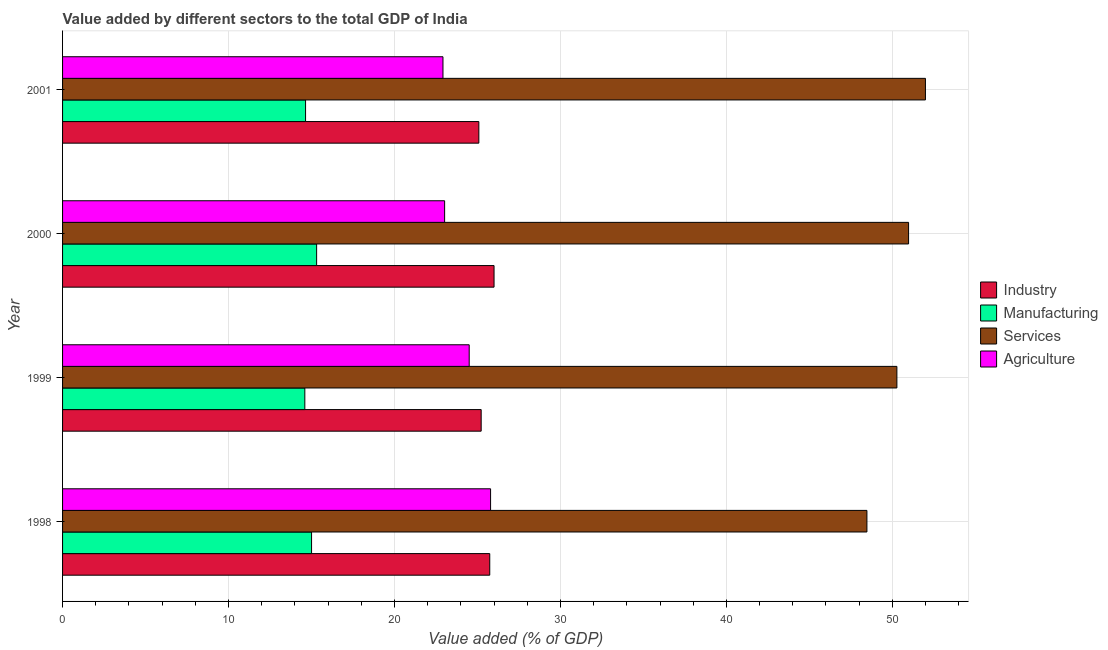How many groups of bars are there?
Keep it short and to the point. 4. Are the number of bars per tick equal to the number of legend labels?
Make the answer very short. Yes. Are the number of bars on each tick of the Y-axis equal?
Provide a succinct answer. Yes. How many bars are there on the 4th tick from the bottom?
Give a very brief answer. 4. In how many cases, is the number of bars for a given year not equal to the number of legend labels?
Make the answer very short. 0. What is the value added by agricultural sector in 2000?
Make the answer very short. 23.02. Across all years, what is the maximum value added by manufacturing sector?
Offer a very short reply. 15.31. Across all years, what is the minimum value added by services sector?
Your answer should be very brief. 48.47. What is the total value added by services sector in the graph?
Your response must be concise. 201.71. What is the difference between the value added by manufacturing sector in 2000 and that in 2001?
Your answer should be compact. 0.67. What is the difference between the value added by manufacturing sector in 2000 and the value added by services sector in 1999?
Ensure brevity in your answer.  -34.96. What is the average value added by services sector per year?
Ensure brevity in your answer.  50.43. In the year 1999, what is the difference between the value added by manufacturing sector and value added by services sector?
Give a very brief answer. -35.68. What is the ratio of the value added by industrial sector in 1999 to that in 2001?
Offer a very short reply. 1.01. What is the difference between the highest and the second highest value added by agricultural sector?
Provide a succinct answer. 1.29. What is the difference between the highest and the lowest value added by agricultural sector?
Provide a succinct answer. 2.87. In how many years, is the value added by services sector greater than the average value added by services sector taken over all years?
Your response must be concise. 2. What does the 4th bar from the top in 1998 represents?
Offer a very short reply. Industry. What does the 2nd bar from the bottom in 2000 represents?
Give a very brief answer. Manufacturing. Is it the case that in every year, the sum of the value added by industrial sector and value added by manufacturing sector is greater than the value added by services sector?
Your answer should be very brief. No. How many bars are there?
Make the answer very short. 16. Are all the bars in the graph horizontal?
Your answer should be compact. Yes. What is the difference between two consecutive major ticks on the X-axis?
Keep it short and to the point. 10. Are the values on the major ticks of X-axis written in scientific E-notation?
Ensure brevity in your answer.  No. Does the graph contain any zero values?
Ensure brevity in your answer.  No. Does the graph contain grids?
Your answer should be compact. Yes. How are the legend labels stacked?
Provide a short and direct response. Vertical. What is the title of the graph?
Make the answer very short. Value added by different sectors to the total GDP of India. What is the label or title of the X-axis?
Ensure brevity in your answer.  Value added (% of GDP). What is the label or title of the Y-axis?
Provide a succinct answer. Year. What is the Value added (% of GDP) in Industry in 1998?
Offer a very short reply. 25.74. What is the Value added (% of GDP) of Manufacturing in 1998?
Give a very brief answer. 15. What is the Value added (% of GDP) in Services in 1998?
Your answer should be compact. 48.47. What is the Value added (% of GDP) of Agriculture in 1998?
Offer a terse response. 25.79. What is the Value added (% of GDP) in Industry in 1999?
Ensure brevity in your answer.  25.22. What is the Value added (% of GDP) in Manufacturing in 1999?
Provide a succinct answer. 14.6. What is the Value added (% of GDP) of Services in 1999?
Give a very brief answer. 50.27. What is the Value added (% of GDP) in Agriculture in 1999?
Make the answer very short. 24.5. What is the Value added (% of GDP) in Industry in 2000?
Ensure brevity in your answer.  26. What is the Value added (% of GDP) in Manufacturing in 2000?
Offer a terse response. 15.31. What is the Value added (% of GDP) of Services in 2000?
Ensure brevity in your answer.  50.98. What is the Value added (% of GDP) in Agriculture in 2000?
Your response must be concise. 23.02. What is the Value added (% of GDP) in Industry in 2001?
Make the answer very short. 25.08. What is the Value added (% of GDP) in Manufacturing in 2001?
Provide a succinct answer. 14.64. What is the Value added (% of GDP) in Services in 2001?
Your response must be concise. 51.99. What is the Value added (% of GDP) in Agriculture in 2001?
Your answer should be compact. 22.92. Across all years, what is the maximum Value added (% of GDP) of Industry?
Your answer should be compact. 26. Across all years, what is the maximum Value added (% of GDP) in Manufacturing?
Offer a very short reply. 15.31. Across all years, what is the maximum Value added (% of GDP) in Services?
Give a very brief answer. 51.99. Across all years, what is the maximum Value added (% of GDP) in Agriculture?
Keep it short and to the point. 25.79. Across all years, what is the minimum Value added (% of GDP) in Industry?
Provide a short and direct response. 25.08. Across all years, what is the minimum Value added (% of GDP) in Manufacturing?
Your response must be concise. 14.6. Across all years, what is the minimum Value added (% of GDP) in Services?
Offer a terse response. 48.47. Across all years, what is the minimum Value added (% of GDP) in Agriculture?
Keep it short and to the point. 22.92. What is the total Value added (% of GDP) of Industry in the graph?
Provide a short and direct response. 102.05. What is the total Value added (% of GDP) in Manufacturing in the graph?
Provide a succinct answer. 59.55. What is the total Value added (% of GDP) of Services in the graph?
Ensure brevity in your answer.  201.71. What is the total Value added (% of GDP) in Agriculture in the graph?
Your response must be concise. 96.24. What is the difference between the Value added (% of GDP) of Industry in 1998 and that in 1999?
Make the answer very short. 0.52. What is the difference between the Value added (% of GDP) of Manufacturing in 1998 and that in 1999?
Offer a very short reply. 0.41. What is the difference between the Value added (% of GDP) of Services in 1998 and that in 1999?
Ensure brevity in your answer.  -1.81. What is the difference between the Value added (% of GDP) of Agriculture in 1998 and that in 1999?
Offer a very short reply. 1.29. What is the difference between the Value added (% of GDP) of Industry in 1998 and that in 2000?
Provide a succinct answer. -0.26. What is the difference between the Value added (% of GDP) of Manufacturing in 1998 and that in 2000?
Provide a succinct answer. -0.31. What is the difference between the Value added (% of GDP) of Services in 1998 and that in 2000?
Your answer should be compact. -2.51. What is the difference between the Value added (% of GDP) in Agriculture in 1998 and that in 2000?
Ensure brevity in your answer.  2.77. What is the difference between the Value added (% of GDP) in Industry in 1998 and that in 2001?
Offer a terse response. 0.66. What is the difference between the Value added (% of GDP) of Manufacturing in 1998 and that in 2001?
Your answer should be compact. 0.36. What is the difference between the Value added (% of GDP) in Services in 1998 and that in 2001?
Provide a succinct answer. -3.53. What is the difference between the Value added (% of GDP) of Agriculture in 1998 and that in 2001?
Give a very brief answer. 2.87. What is the difference between the Value added (% of GDP) in Industry in 1999 and that in 2000?
Provide a short and direct response. -0.78. What is the difference between the Value added (% of GDP) in Manufacturing in 1999 and that in 2000?
Keep it short and to the point. -0.71. What is the difference between the Value added (% of GDP) in Services in 1999 and that in 2000?
Your response must be concise. -0.7. What is the difference between the Value added (% of GDP) of Agriculture in 1999 and that in 2000?
Provide a succinct answer. 1.48. What is the difference between the Value added (% of GDP) in Industry in 1999 and that in 2001?
Provide a succinct answer. 0.14. What is the difference between the Value added (% of GDP) in Manufacturing in 1999 and that in 2001?
Ensure brevity in your answer.  -0.04. What is the difference between the Value added (% of GDP) of Services in 1999 and that in 2001?
Your answer should be compact. -1.72. What is the difference between the Value added (% of GDP) in Agriculture in 1999 and that in 2001?
Provide a short and direct response. 1.58. What is the difference between the Value added (% of GDP) of Industry in 2000 and that in 2001?
Make the answer very short. 0.92. What is the difference between the Value added (% of GDP) of Manufacturing in 2000 and that in 2001?
Ensure brevity in your answer.  0.67. What is the difference between the Value added (% of GDP) of Services in 2000 and that in 2001?
Provide a short and direct response. -1.02. What is the difference between the Value added (% of GDP) of Agriculture in 2000 and that in 2001?
Provide a succinct answer. 0.1. What is the difference between the Value added (% of GDP) of Industry in 1998 and the Value added (% of GDP) of Manufacturing in 1999?
Give a very brief answer. 11.14. What is the difference between the Value added (% of GDP) of Industry in 1998 and the Value added (% of GDP) of Services in 1999?
Provide a short and direct response. -24.53. What is the difference between the Value added (% of GDP) in Industry in 1998 and the Value added (% of GDP) in Agriculture in 1999?
Keep it short and to the point. 1.24. What is the difference between the Value added (% of GDP) of Manufacturing in 1998 and the Value added (% of GDP) of Services in 1999?
Your answer should be compact. -35.27. What is the difference between the Value added (% of GDP) of Manufacturing in 1998 and the Value added (% of GDP) of Agriculture in 1999?
Provide a short and direct response. -9.5. What is the difference between the Value added (% of GDP) in Services in 1998 and the Value added (% of GDP) in Agriculture in 1999?
Give a very brief answer. 23.97. What is the difference between the Value added (% of GDP) in Industry in 1998 and the Value added (% of GDP) in Manufacturing in 2000?
Keep it short and to the point. 10.43. What is the difference between the Value added (% of GDP) in Industry in 1998 and the Value added (% of GDP) in Services in 2000?
Offer a very short reply. -25.24. What is the difference between the Value added (% of GDP) in Industry in 1998 and the Value added (% of GDP) in Agriculture in 2000?
Offer a very short reply. 2.72. What is the difference between the Value added (% of GDP) of Manufacturing in 1998 and the Value added (% of GDP) of Services in 2000?
Your answer should be very brief. -35.97. What is the difference between the Value added (% of GDP) of Manufacturing in 1998 and the Value added (% of GDP) of Agriculture in 2000?
Your answer should be very brief. -8.02. What is the difference between the Value added (% of GDP) of Services in 1998 and the Value added (% of GDP) of Agriculture in 2000?
Your answer should be very brief. 25.45. What is the difference between the Value added (% of GDP) in Industry in 1998 and the Value added (% of GDP) in Manufacturing in 2001?
Offer a very short reply. 11.1. What is the difference between the Value added (% of GDP) in Industry in 1998 and the Value added (% of GDP) in Services in 2001?
Keep it short and to the point. -26.25. What is the difference between the Value added (% of GDP) of Industry in 1998 and the Value added (% of GDP) of Agriculture in 2001?
Offer a terse response. 2.82. What is the difference between the Value added (% of GDP) of Manufacturing in 1998 and the Value added (% of GDP) of Services in 2001?
Keep it short and to the point. -36.99. What is the difference between the Value added (% of GDP) in Manufacturing in 1998 and the Value added (% of GDP) in Agriculture in 2001?
Your answer should be very brief. -7.92. What is the difference between the Value added (% of GDP) of Services in 1998 and the Value added (% of GDP) of Agriculture in 2001?
Ensure brevity in your answer.  25.55. What is the difference between the Value added (% of GDP) of Industry in 1999 and the Value added (% of GDP) of Manufacturing in 2000?
Provide a short and direct response. 9.92. What is the difference between the Value added (% of GDP) of Industry in 1999 and the Value added (% of GDP) of Services in 2000?
Ensure brevity in your answer.  -25.75. What is the difference between the Value added (% of GDP) in Industry in 1999 and the Value added (% of GDP) in Agriculture in 2000?
Offer a very short reply. 2.2. What is the difference between the Value added (% of GDP) in Manufacturing in 1999 and the Value added (% of GDP) in Services in 2000?
Your response must be concise. -36.38. What is the difference between the Value added (% of GDP) of Manufacturing in 1999 and the Value added (% of GDP) of Agriculture in 2000?
Your response must be concise. -8.42. What is the difference between the Value added (% of GDP) in Services in 1999 and the Value added (% of GDP) in Agriculture in 2000?
Keep it short and to the point. 27.25. What is the difference between the Value added (% of GDP) in Industry in 1999 and the Value added (% of GDP) in Manufacturing in 2001?
Your answer should be compact. 10.58. What is the difference between the Value added (% of GDP) in Industry in 1999 and the Value added (% of GDP) in Services in 2001?
Give a very brief answer. -26.77. What is the difference between the Value added (% of GDP) in Industry in 1999 and the Value added (% of GDP) in Agriculture in 2001?
Your response must be concise. 2.3. What is the difference between the Value added (% of GDP) of Manufacturing in 1999 and the Value added (% of GDP) of Services in 2001?
Keep it short and to the point. -37.4. What is the difference between the Value added (% of GDP) of Manufacturing in 1999 and the Value added (% of GDP) of Agriculture in 2001?
Provide a short and direct response. -8.32. What is the difference between the Value added (% of GDP) in Services in 1999 and the Value added (% of GDP) in Agriculture in 2001?
Your answer should be very brief. 27.35. What is the difference between the Value added (% of GDP) of Industry in 2000 and the Value added (% of GDP) of Manufacturing in 2001?
Provide a succinct answer. 11.36. What is the difference between the Value added (% of GDP) in Industry in 2000 and the Value added (% of GDP) in Services in 2001?
Your response must be concise. -25.99. What is the difference between the Value added (% of GDP) of Industry in 2000 and the Value added (% of GDP) of Agriculture in 2001?
Ensure brevity in your answer.  3.08. What is the difference between the Value added (% of GDP) of Manufacturing in 2000 and the Value added (% of GDP) of Services in 2001?
Your response must be concise. -36.69. What is the difference between the Value added (% of GDP) of Manufacturing in 2000 and the Value added (% of GDP) of Agriculture in 2001?
Your response must be concise. -7.61. What is the difference between the Value added (% of GDP) in Services in 2000 and the Value added (% of GDP) in Agriculture in 2001?
Make the answer very short. 28.06. What is the average Value added (% of GDP) in Industry per year?
Offer a terse response. 25.51. What is the average Value added (% of GDP) of Manufacturing per year?
Your answer should be very brief. 14.89. What is the average Value added (% of GDP) in Services per year?
Keep it short and to the point. 50.43. What is the average Value added (% of GDP) of Agriculture per year?
Provide a short and direct response. 24.06. In the year 1998, what is the difference between the Value added (% of GDP) in Industry and Value added (% of GDP) in Manufacturing?
Your answer should be compact. 10.74. In the year 1998, what is the difference between the Value added (% of GDP) of Industry and Value added (% of GDP) of Services?
Offer a terse response. -22.73. In the year 1998, what is the difference between the Value added (% of GDP) of Industry and Value added (% of GDP) of Agriculture?
Offer a very short reply. -0.05. In the year 1998, what is the difference between the Value added (% of GDP) in Manufacturing and Value added (% of GDP) in Services?
Make the answer very short. -33.46. In the year 1998, what is the difference between the Value added (% of GDP) in Manufacturing and Value added (% of GDP) in Agriculture?
Offer a terse response. -10.79. In the year 1998, what is the difference between the Value added (% of GDP) of Services and Value added (% of GDP) of Agriculture?
Give a very brief answer. 22.68. In the year 1999, what is the difference between the Value added (% of GDP) of Industry and Value added (% of GDP) of Manufacturing?
Your answer should be compact. 10.63. In the year 1999, what is the difference between the Value added (% of GDP) of Industry and Value added (% of GDP) of Services?
Offer a terse response. -25.05. In the year 1999, what is the difference between the Value added (% of GDP) of Industry and Value added (% of GDP) of Agriculture?
Offer a terse response. 0.72. In the year 1999, what is the difference between the Value added (% of GDP) in Manufacturing and Value added (% of GDP) in Services?
Give a very brief answer. -35.68. In the year 1999, what is the difference between the Value added (% of GDP) of Manufacturing and Value added (% of GDP) of Agriculture?
Provide a succinct answer. -9.9. In the year 1999, what is the difference between the Value added (% of GDP) in Services and Value added (% of GDP) in Agriculture?
Your answer should be compact. 25.77. In the year 2000, what is the difference between the Value added (% of GDP) of Industry and Value added (% of GDP) of Manufacturing?
Your answer should be compact. 10.69. In the year 2000, what is the difference between the Value added (% of GDP) in Industry and Value added (% of GDP) in Services?
Provide a succinct answer. -24.98. In the year 2000, what is the difference between the Value added (% of GDP) in Industry and Value added (% of GDP) in Agriculture?
Ensure brevity in your answer.  2.98. In the year 2000, what is the difference between the Value added (% of GDP) of Manufacturing and Value added (% of GDP) of Services?
Provide a short and direct response. -35.67. In the year 2000, what is the difference between the Value added (% of GDP) of Manufacturing and Value added (% of GDP) of Agriculture?
Provide a succinct answer. -7.71. In the year 2000, what is the difference between the Value added (% of GDP) of Services and Value added (% of GDP) of Agriculture?
Ensure brevity in your answer.  27.96. In the year 2001, what is the difference between the Value added (% of GDP) in Industry and Value added (% of GDP) in Manufacturing?
Your answer should be compact. 10.44. In the year 2001, what is the difference between the Value added (% of GDP) in Industry and Value added (% of GDP) in Services?
Keep it short and to the point. -26.91. In the year 2001, what is the difference between the Value added (% of GDP) of Industry and Value added (% of GDP) of Agriculture?
Give a very brief answer. 2.16. In the year 2001, what is the difference between the Value added (% of GDP) in Manufacturing and Value added (% of GDP) in Services?
Your response must be concise. -37.35. In the year 2001, what is the difference between the Value added (% of GDP) in Manufacturing and Value added (% of GDP) in Agriculture?
Make the answer very short. -8.28. In the year 2001, what is the difference between the Value added (% of GDP) in Services and Value added (% of GDP) in Agriculture?
Ensure brevity in your answer.  29.07. What is the ratio of the Value added (% of GDP) in Industry in 1998 to that in 1999?
Give a very brief answer. 1.02. What is the ratio of the Value added (% of GDP) of Manufacturing in 1998 to that in 1999?
Your response must be concise. 1.03. What is the ratio of the Value added (% of GDP) in Services in 1998 to that in 1999?
Your response must be concise. 0.96. What is the ratio of the Value added (% of GDP) in Agriculture in 1998 to that in 1999?
Your response must be concise. 1.05. What is the ratio of the Value added (% of GDP) of Manufacturing in 1998 to that in 2000?
Your response must be concise. 0.98. What is the ratio of the Value added (% of GDP) of Services in 1998 to that in 2000?
Your answer should be very brief. 0.95. What is the ratio of the Value added (% of GDP) in Agriculture in 1998 to that in 2000?
Give a very brief answer. 1.12. What is the ratio of the Value added (% of GDP) of Industry in 1998 to that in 2001?
Your answer should be compact. 1.03. What is the ratio of the Value added (% of GDP) of Manufacturing in 1998 to that in 2001?
Provide a short and direct response. 1.02. What is the ratio of the Value added (% of GDP) of Services in 1998 to that in 2001?
Keep it short and to the point. 0.93. What is the ratio of the Value added (% of GDP) in Agriculture in 1998 to that in 2001?
Make the answer very short. 1.13. What is the ratio of the Value added (% of GDP) of Industry in 1999 to that in 2000?
Your response must be concise. 0.97. What is the ratio of the Value added (% of GDP) in Manufacturing in 1999 to that in 2000?
Offer a terse response. 0.95. What is the ratio of the Value added (% of GDP) of Services in 1999 to that in 2000?
Give a very brief answer. 0.99. What is the ratio of the Value added (% of GDP) in Agriculture in 1999 to that in 2000?
Provide a succinct answer. 1.06. What is the ratio of the Value added (% of GDP) in Industry in 1999 to that in 2001?
Provide a succinct answer. 1.01. What is the ratio of the Value added (% of GDP) in Services in 1999 to that in 2001?
Make the answer very short. 0.97. What is the ratio of the Value added (% of GDP) of Agriculture in 1999 to that in 2001?
Keep it short and to the point. 1.07. What is the ratio of the Value added (% of GDP) in Industry in 2000 to that in 2001?
Your answer should be very brief. 1.04. What is the ratio of the Value added (% of GDP) in Manufacturing in 2000 to that in 2001?
Your answer should be very brief. 1.05. What is the ratio of the Value added (% of GDP) of Services in 2000 to that in 2001?
Provide a short and direct response. 0.98. What is the difference between the highest and the second highest Value added (% of GDP) in Industry?
Give a very brief answer. 0.26. What is the difference between the highest and the second highest Value added (% of GDP) in Manufacturing?
Your answer should be compact. 0.31. What is the difference between the highest and the second highest Value added (% of GDP) in Services?
Offer a very short reply. 1.02. What is the difference between the highest and the second highest Value added (% of GDP) in Agriculture?
Make the answer very short. 1.29. What is the difference between the highest and the lowest Value added (% of GDP) in Industry?
Offer a terse response. 0.92. What is the difference between the highest and the lowest Value added (% of GDP) in Manufacturing?
Offer a terse response. 0.71. What is the difference between the highest and the lowest Value added (% of GDP) of Services?
Ensure brevity in your answer.  3.53. What is the difference between the highest and the lowest Value added (% of GDP) in Agriculture?
Provide a short and direct response. 2.87. 